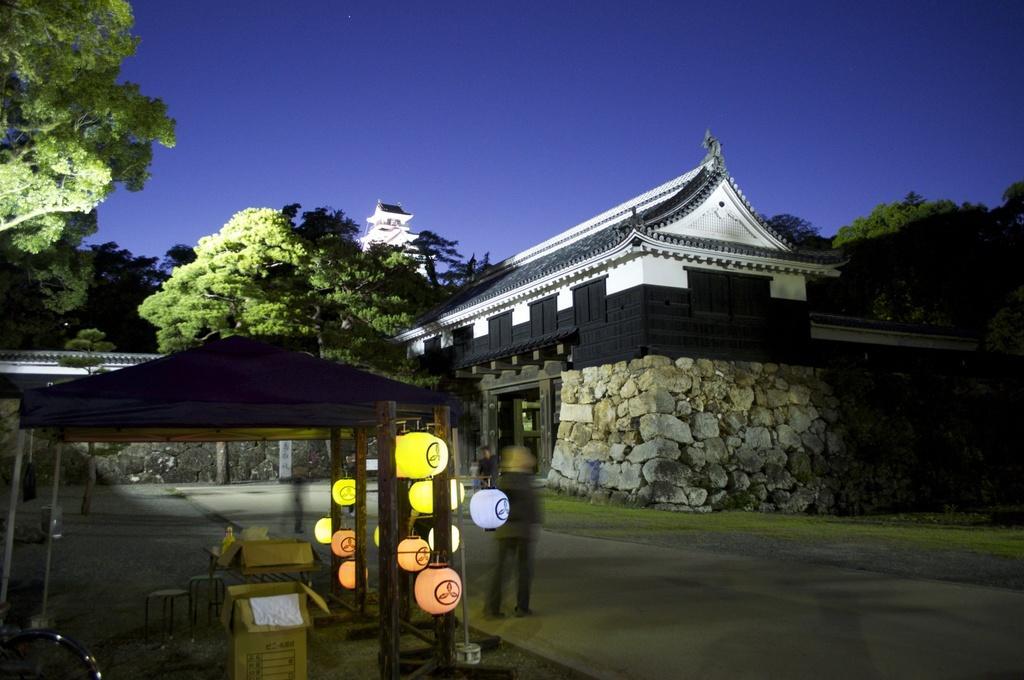How would you summarize this image in a sentence or two? In this image we can see persons standing on the road, cardboard cartons, benches, paper lanterns, shed, buildings, trees and sky. 